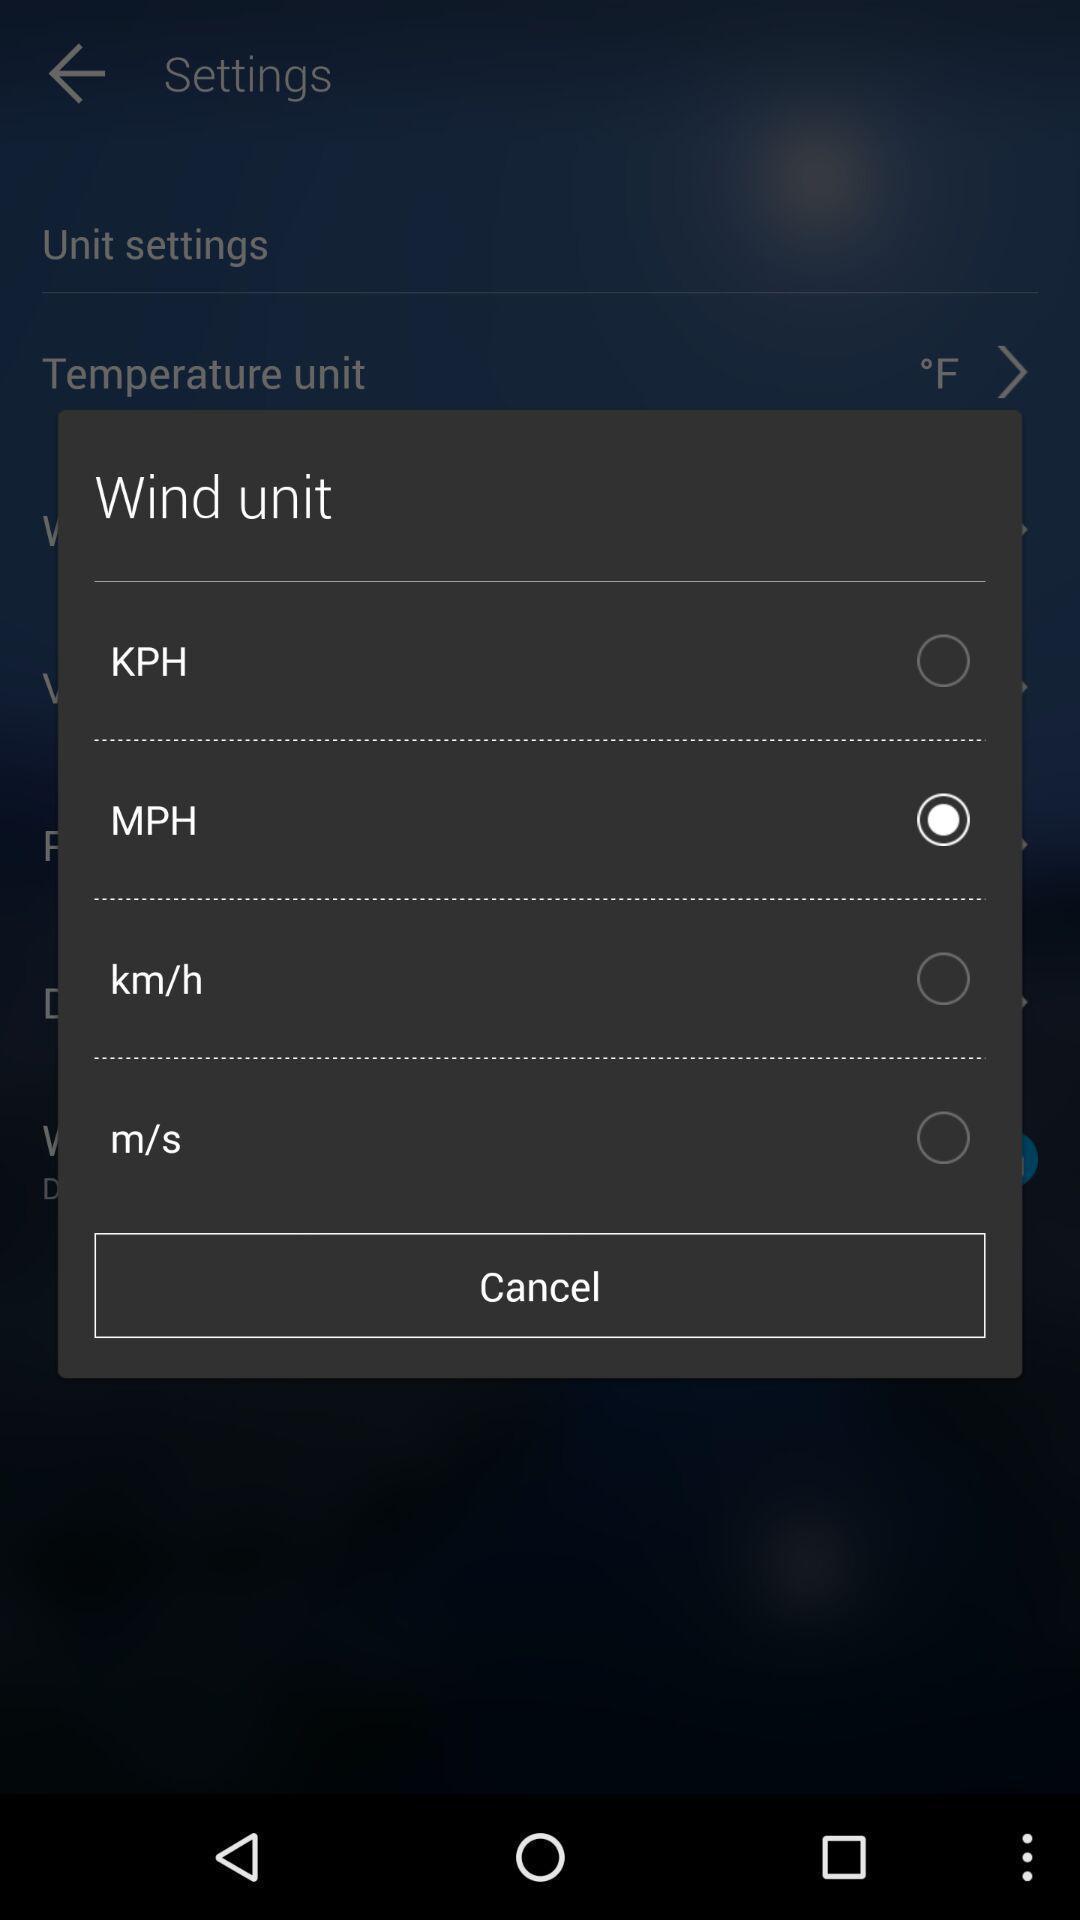What details can you identify in this image? Pop-up to select the distance per time. 